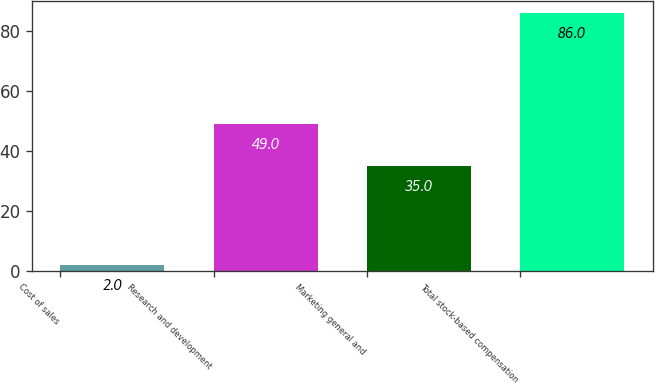Convert chart. <chart><loc_0><loc_0><loc_500><loc_500><bar_chart><fcel>Cost of sales<fcel>Research and development<fcel>Marketing general and<fcel>Total stock-based compensation<nl><fcel>2<fcel>49<fcel>35<fcel>86<nl></chart> 